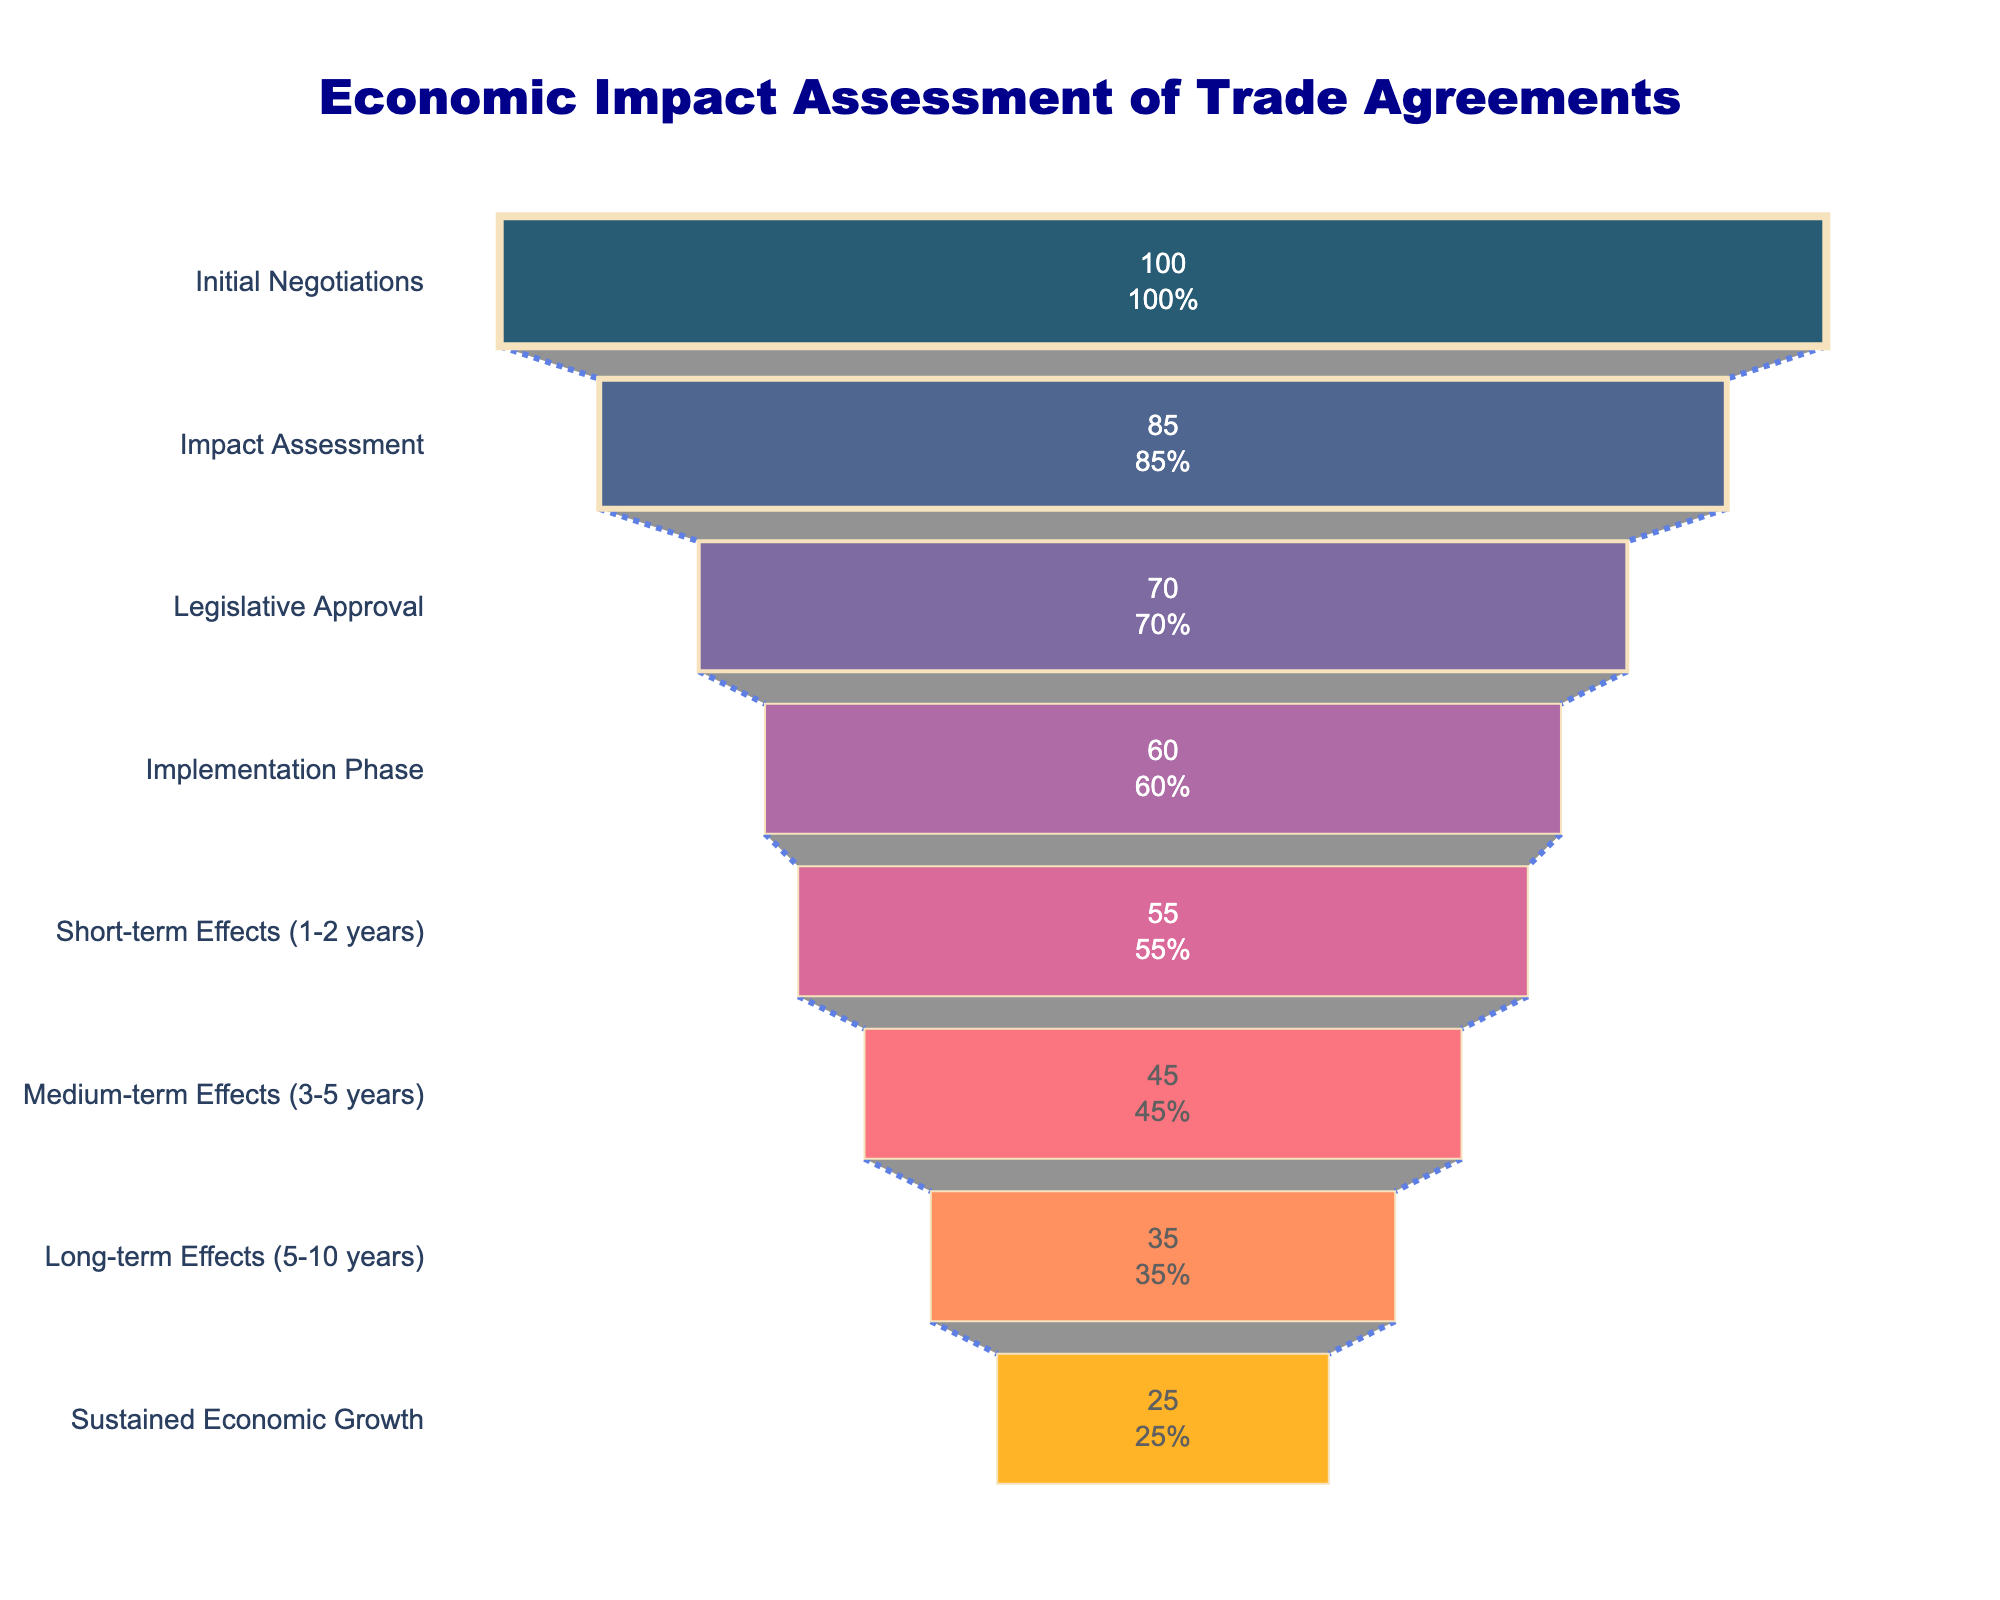What's the title of the figure? The title is located at the top center of the figure and provides a description of what the chart is depicting. It reads "Economic Impact Assessment of Trade Agreements".
Answer: Economic Impact Assessment of Trade Agreements How many stages are represented in the funnel chart? By counting the y-axis labels, we see the funnel chart has 8 stages listed.
Answer: 8 What is the value at the "Impact Assessment" stage? The value for each stage is displayed prominently within the funnel segments. For the "Impact Assessment" stage, it is 85.
Answer: 85 Which stage has the lowest value? The values for each stage are shown inside the funnel segments. The "Sustained Economic Growth" stage has the lowest value, which is 25.
Answer: Sustained Economic Growth What is the percentage of the value at "Short-term Effects (1-2 years)" compared to the initial value? The percentage is displayed inside the funnel segment. For "Short-term Effects (1-2 years)", the percentage of the initial value is 55%.
Answer: 55% How much does the value decrease from "Legislative Approval" to "Implementation Phase"? Subtract the value of the "Implementation Phase" stage (60) from the value of the "Legislative Approval" stage (70). The decrease is 70 - 60 = 10.
Answer: 10 Compare the value at "Medium-term Effects (3-5 years)" to "Long-term Effects (5-10 years)". Which one is greater? Compare the values in the funnel: "Medium-term Effects (3-5 years)" has a value of 45, while "Long-term Effects (5-10 years)" has a value of 35. Thus, "Medium-term Effects" is greater.
Answer: Medium-term Effects (3-5 years) What is the cumulative decrease in value from "Initial Negotiations" to "Sustained Economic Growth"? Sum the individual decreases between each consecutive stage: (100-85) + (85-70) + (70-60) + (60-55) + (55-45) + (45-35) + (35-25) = 15 + 15 + 10 + 5 + 10 + 10 + 10 = 75.
Answer: 75 What percentage of the initial value is achieved by the "Medium-term Effects (3-5 years)" stage? The percentage for each stage is given. For "Medium-term Effects (3-5 years)", it shows as 45% of the initial value.
Answer: 45% How does the chart visually represent the connection between stages? Observing the figure, the funnel chart uses a connector line with dots and royal blue color to visually link the stages, highlighting the flow from one stage to the next.
Answer: Connector line 